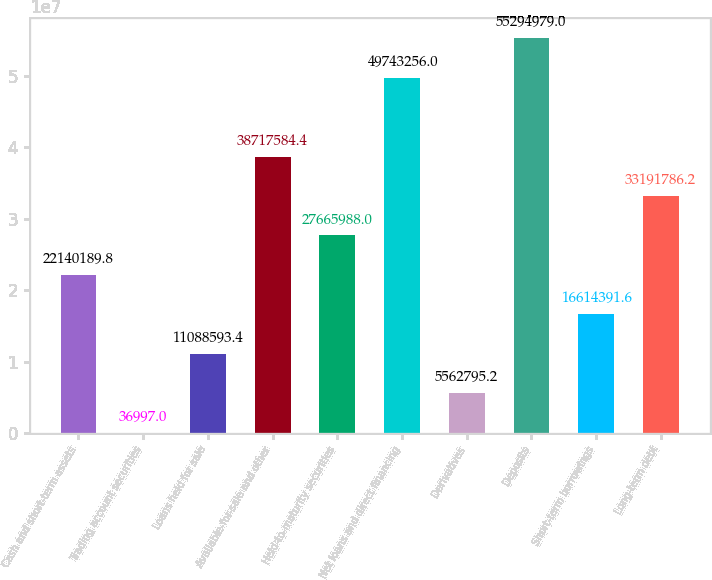Convert chart to OTSL. <chart><loc_0><loc_0><loc_500><loc_500><bar_chart><fcel>Cash and short-term assets<fcel>Trading account securities<fcel>Loans held for sale<fcel>Available-for-sale and other<fcel>Held-to-maturity securities<fcel>Net loans and direct financing<fcel>Derivatives<fcel>Deposits<fcel>Short-term borrowings<fcel>Long-term debt<nl><fcel>2.21402e+07<fcel>36997<fcel>1.10886e+07<fcel>3.87176e+07<fcel>2.7666e+07<fcel>4.97433e+07<fcel>5.5628e+06<fcel>5.5295e+07<fcel>1.66144e+07<fcel>3.31918e+07<nl></chart> 